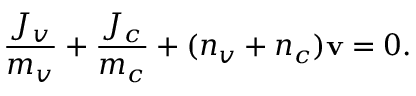<formula> <loc_0><loc_0><loc_500><loc_500>\frac { J _ { v } } { m _ { v } } + \frac { J _ { c } } { m _ { c } } + ( n _ { v } + n _ { c } ) v = 0 .</formula> 